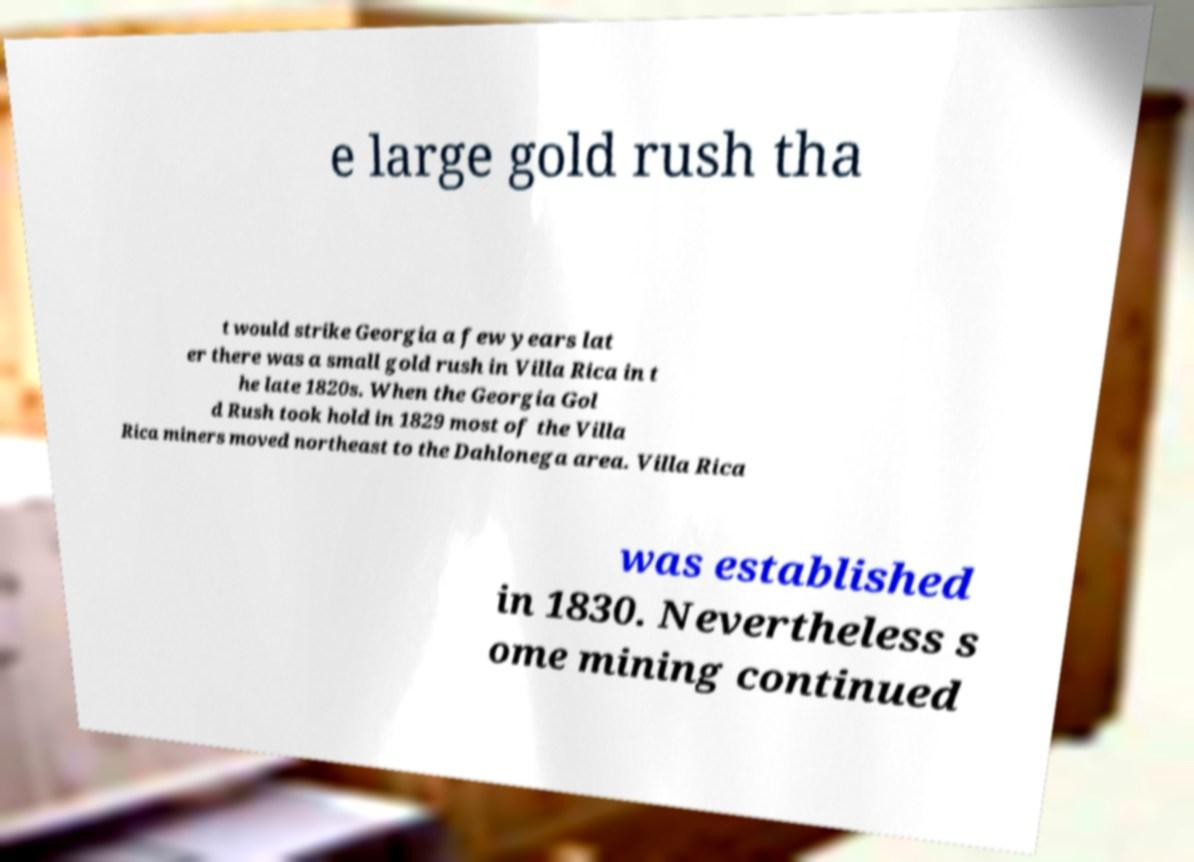There's text embedded in this image that I need extracted. Can you transcribe it verbatim? e large gold rush tha t would strike Georgia a few years lat er there was a small gold rush in Villa Rica in t he late 1820s. When the Georgia Gol d Rush took hold in 1829 most of the Villa Rica miners moved northeast to the Dahlonega area. Villa Rica was established in 1830. Nevertheless s ome mining continued 